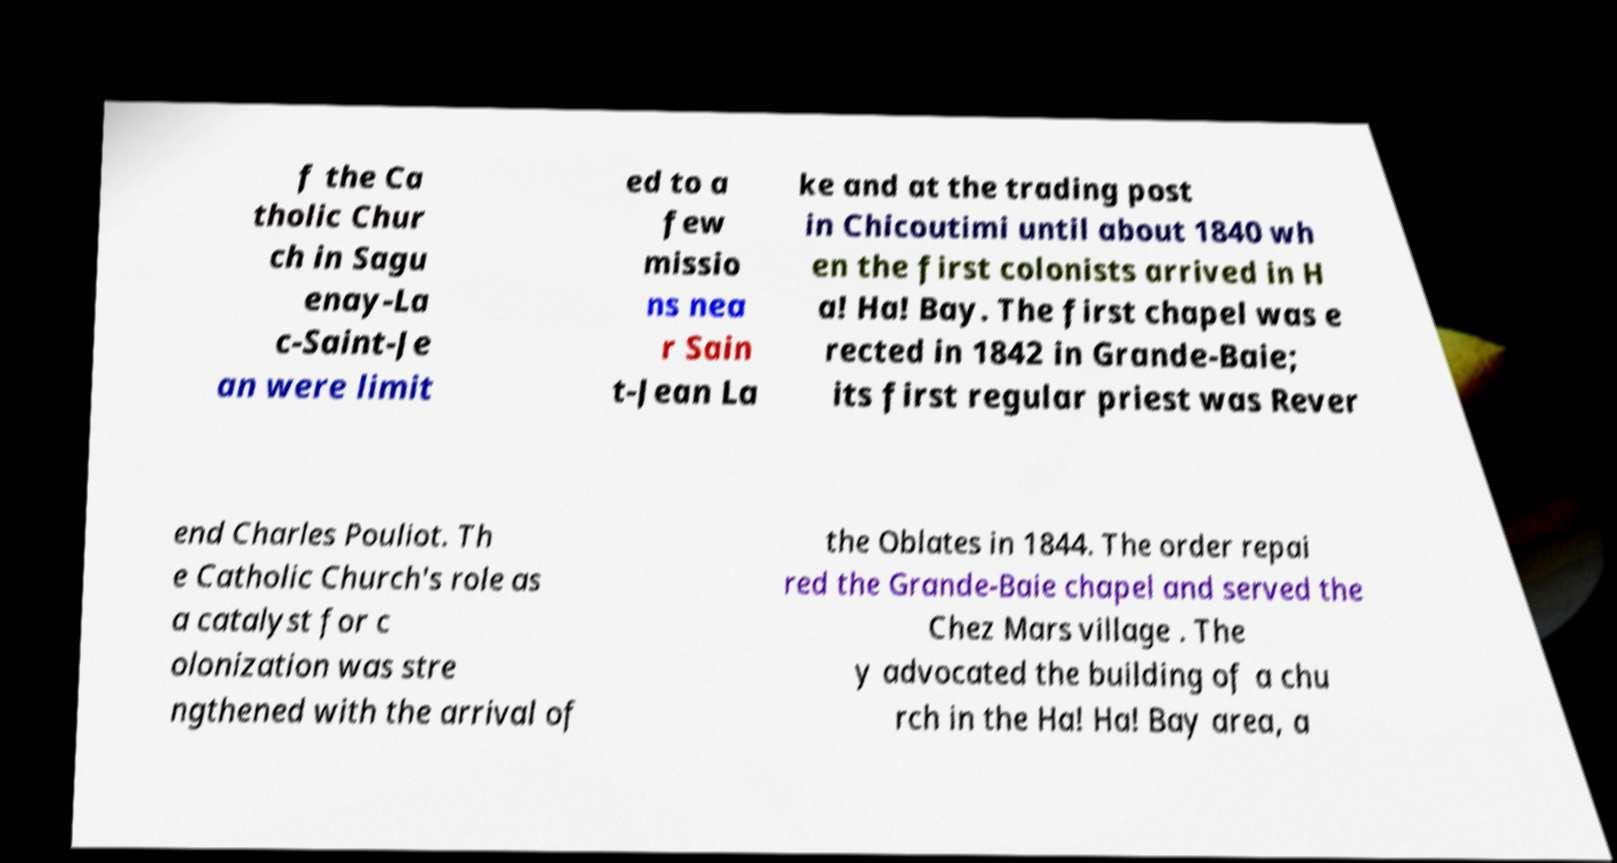Can you accurately transcribe the text from the provided image for me? f the Ca tholic Chur ch in Sagu enay-La c-Saint-Je an were limit ed to a few missio ns nea r Sain t-Jean La ke and at the trading post in Chicoutimi until about 1840 wh en the first colonists arrived in H a! Ha! Bay. The first chapel was e rected in 1842 in Grande-Baie; its first regular priest was Rever end Charles Pouliot. Th e Catholic Church's role as a catalyst for c olonization was stre ngthened with the arrival of the Oblates in 1844. The order repai red the Grande-Baie chapel and served the Chez Mars village . The y advocated the building of a chu rch in the Ha! Ha! Bay area, a 